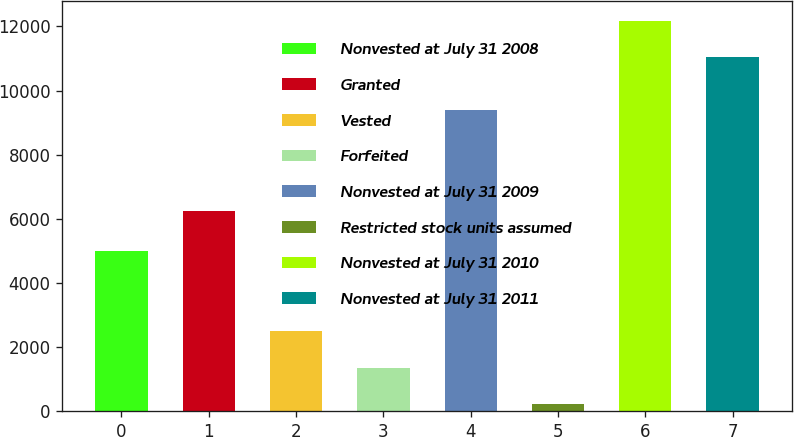<chart> <loc_0><loc_0><loc_500><loc_500><bar_chart><fcel>Nonvested at July 31 2008<fcel>Granted<fcel>Vested<fcel>Forfeited<fcel>Nonvested at July 31 2009<fcel>Restricted stock units assumed<fcel>Nonvested at July 31 2010<fcel>Nonvested at July 31 2011<nl><fcel>4997<fcel>6242<fcel>2491<fcel>1361<fcel>9398<fcel>231<fcel>12185<fcel>11055<nl></chart> 